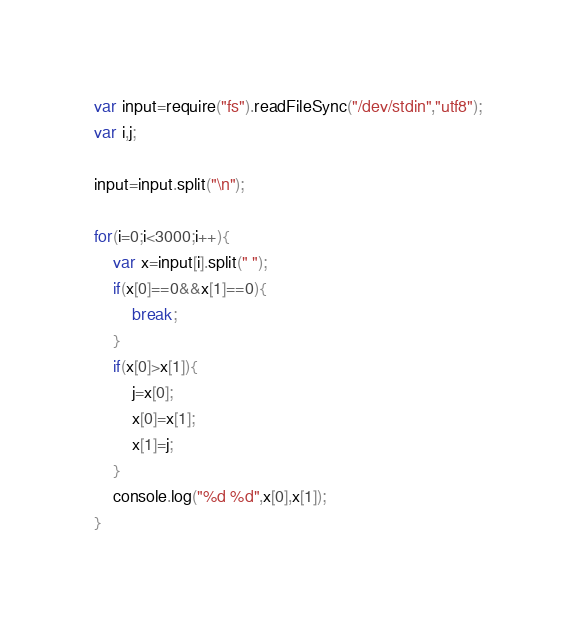<code> <loc_0><loc_0><loc_500><loc_500><_JavaScript_>var input=require("fs").readFileSync("/dev/stdin","utf8");
var i,j;

input=input.split("\n");

for(i=0;i<3000;i++){
    var x=input[i].split(" ");
    if(x[0]==0&&x[1]==0){
        break;
    }
    if(x[0]>x[1]){
        j=x[0];
        x[0]=x[1];
        x[1]=j;
    }
    console.log("%d %d",x[0],x[1]);
}
</code> 